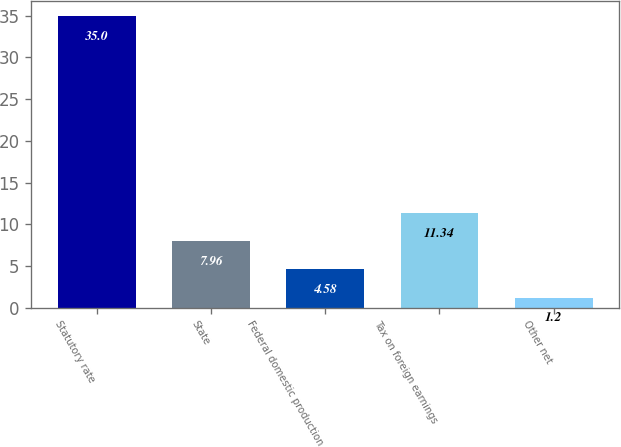Convert chart to OTSL. <chart><loc_0><loc_0><loc_500><loc_500><bar_chart><fcel>Statutory rate<fcel>State<fcel>Federal domestic production<fcel>Tax on foreign earnings<fcel>Other net<nl><fcel>35<fcel>7.96<fcel>4.58<fcel>11.34<fcel>1.2<nl></chart> 